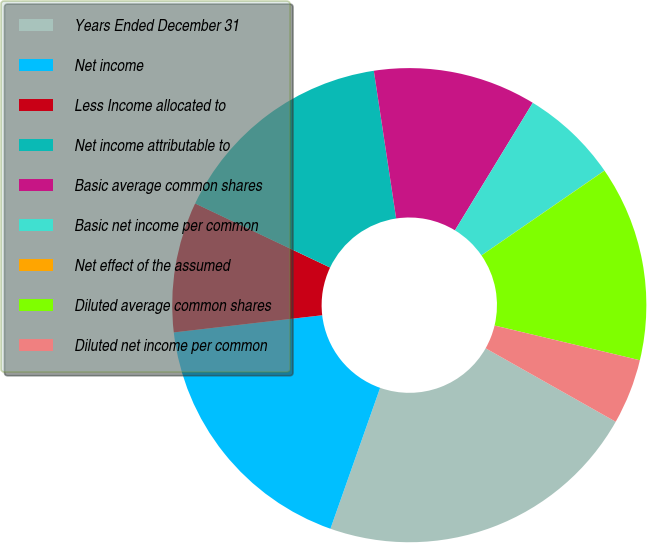Convert chart. <chart><loc_0><loc_0><loc_500><loc_500><pie_chart><fcel>Years Ended December 31<fcel>Net income<fcel>Less Income allocated to<fcel>Net income attributable to<fcel>Basic average common shares<fcel>Basic net income per common<fcel>Net effect of the assumed<fcel>Diluted average common shares<fcel>Diluted net income per common<nl><fcel>22.21%<fcel>17.77%<fcel>8.89%<fcel>15.55%<fcel>11.11%<fcel>6.67%<fcel>0.01%<fcel>13.33%<fcel>4.45%<nl></chart> 